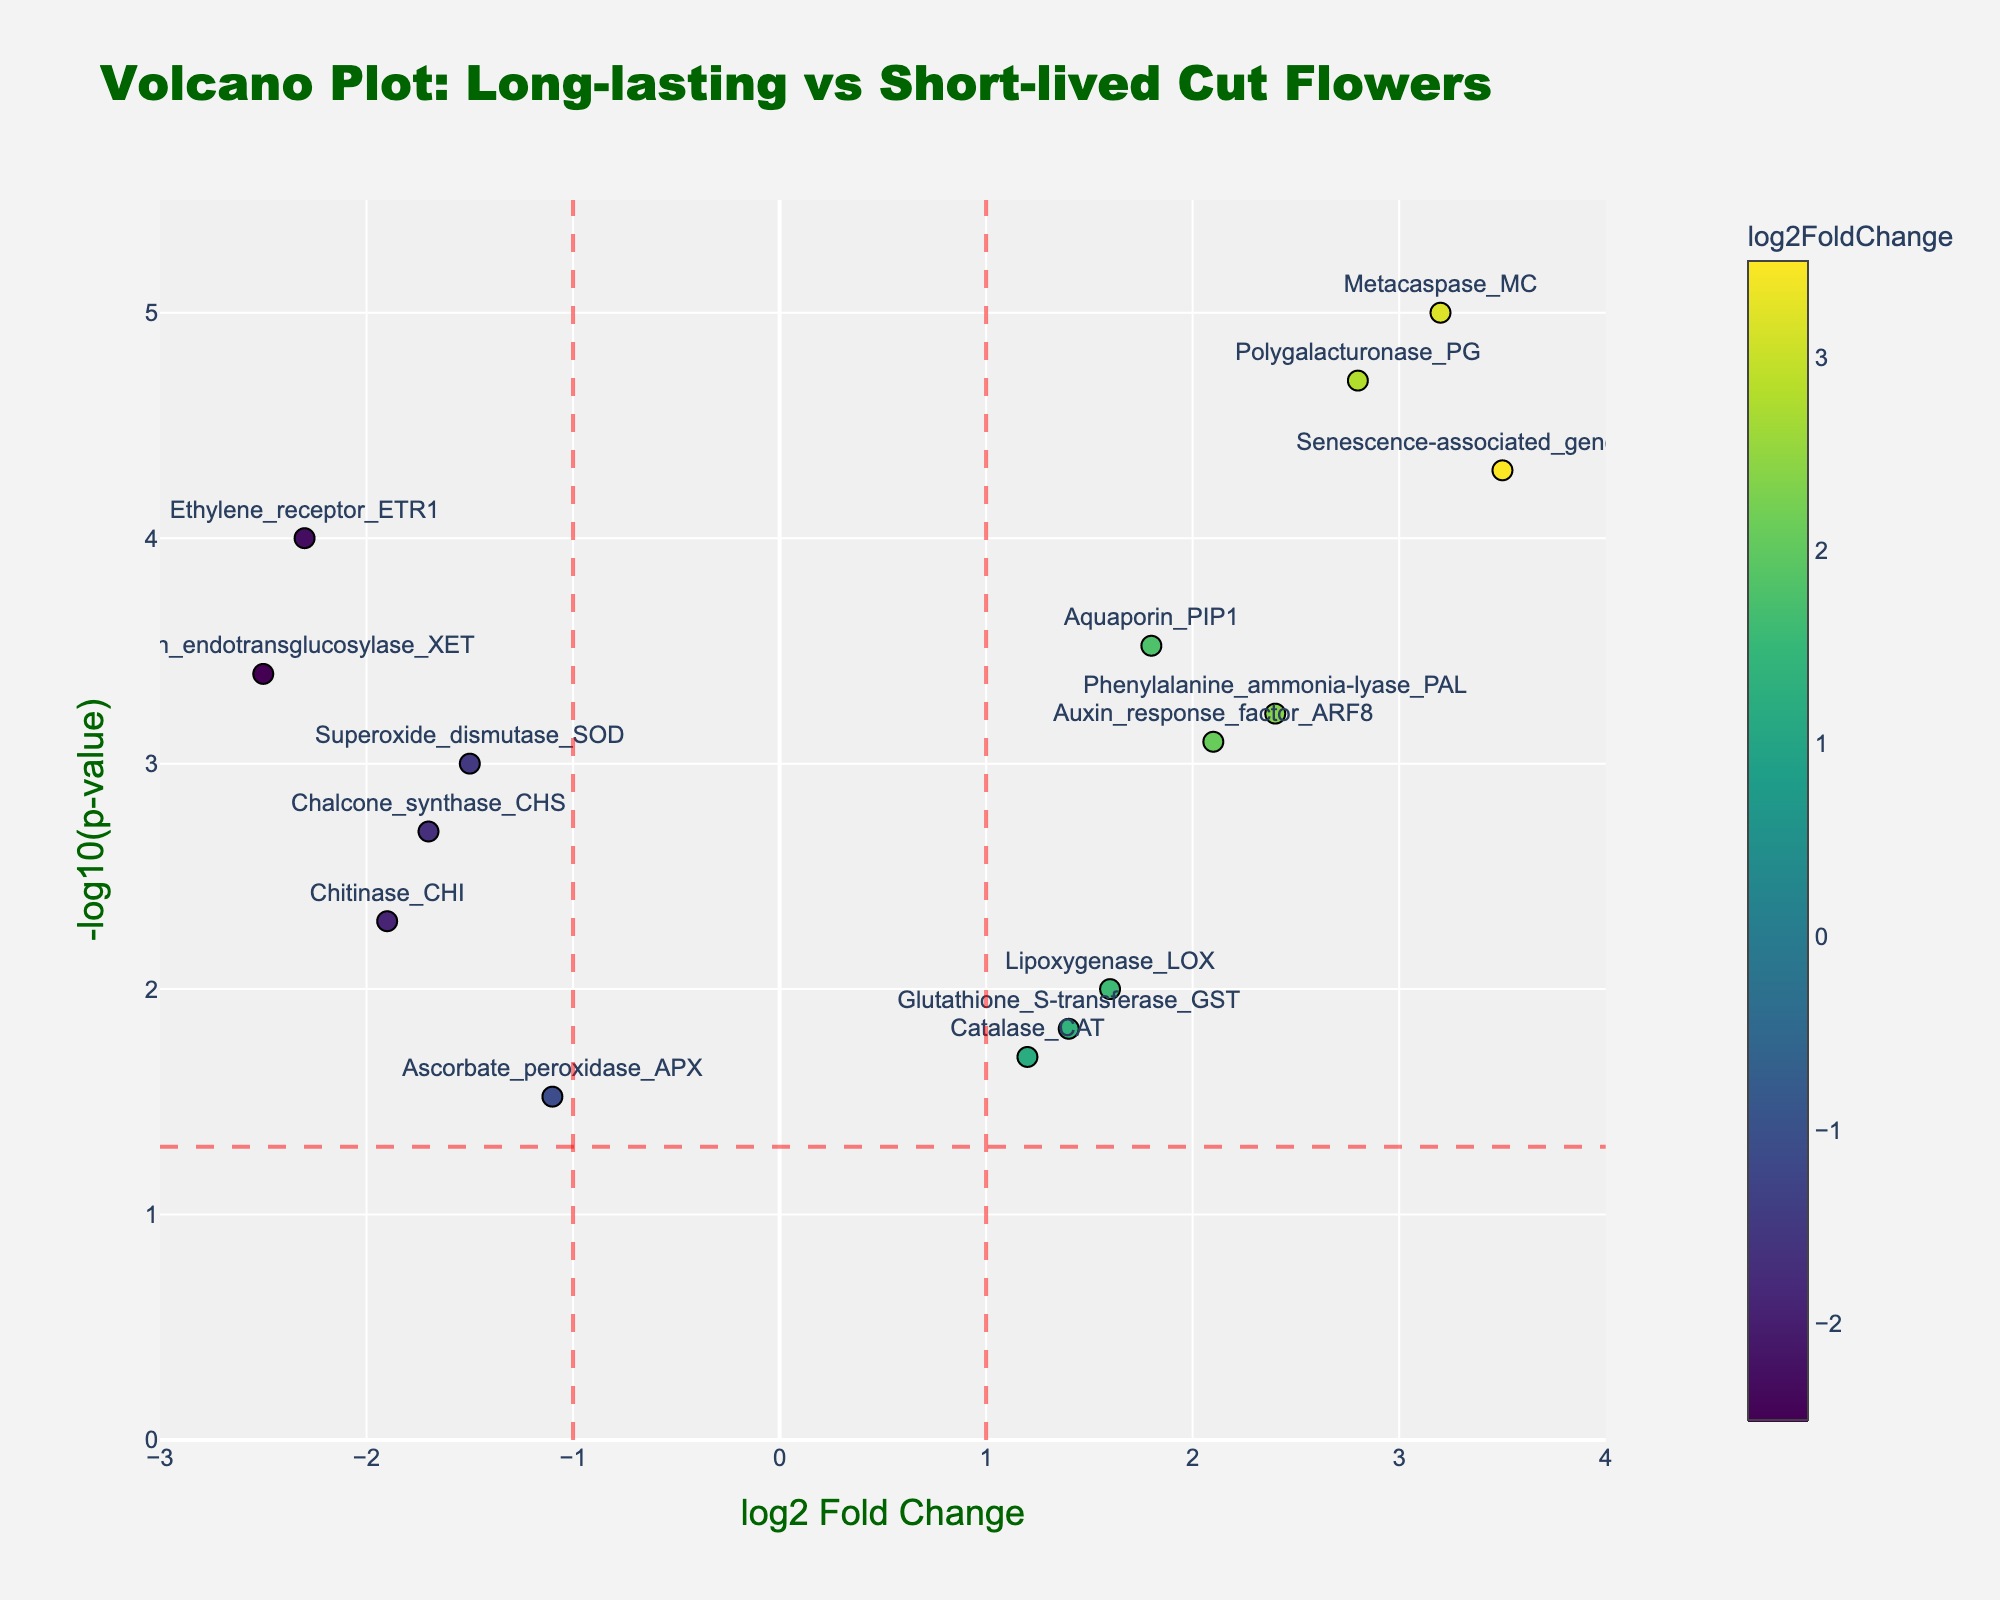What is the title of the figure? The title is displayed at the top of the plot.
Answer: Volcano Plot: Long-lasting vs Short-lived Cut Flowers How many genes have a log2 fold change greater than 2? By looking at the x-axis values, we count the data points to the right of the vertical red dashed line at x=2.
Answer: 4 Which gene has the highest -log10(p-value)? The highest point on the y-axis corresponds to the gene with the highest -log10(p-value).
Answer: Metacaspase_MC What is the log2 fold change for the gene Ethylene_receptor_ETR1? Find the data point labeled 'Ethylene_receptor_ETR1' and read off its x-axis value.
Answer: -2.3 How many genes have a p-value less than 0.01? Identify the data points above the horizontal red dashed line (since -log10(0.01) = 2) and count them.
Answer: 9 What is the range of -log10(p-value) in the plot? Observe the lowest and highest y-axis values plotted.
Answer: 0 to 5.5 Which gene has a log2 fold change closest to zero but is still statistically significant (p-value < 0.05)? Look for the genes nearest to the x=0 line (vertical) but above the horizontal red dashed line, then identify the closest to zero.
Answer: Catalase_CAT Which gene shows the greatest positive log2 fold change? Find the rightmost data point on the plot to determine the gene with the highest x-axis value.
Answer: Senescence-associated_gene_SAG12 Compare the significance level of Aquaporin_PIP1 and Superoxide_dismutase_SOD. Which one has a higher significance level? Compare the heights (y-axis values, -log10(p-value)) of the points labeled 'Aquaporin_PIP1' and 'Superoxide_dismutase_SOD'. Higher y-axis value means higher significance.
Answer: Aquaporin_PIP1 What are the threshold lines for log2 fold change and p-value indicated on the plot? Observe the positions of the vertical and horizontal red dashed lines. The vertical lines are at x=-1 and x=1, and the horizontal line is at y=-log10(0.05).
Answer: log2 fold change: -1 and 1, p-value: 0.05 